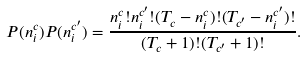<formula> <loc_0><loc_0><loc_500><loc_500>P ( n ^ { c } _ { i } ) P ( n ^ { c ^ { \prime } } _ { i } ) = \frac { n ^ { c } _ { i } ! n ^ { c ^ { \prime } } _ { i } ! ( T _ { c } - n ^ { c } _ { i } ) ! ( T _ { c ^ { \prime } } - n ^ { c ^ { \prime } } _ { i } ) ! } { ( T _ { c } + 1 ) ! ( T _ { c ^ { \prime } } + 1 ) ! } .</formula> 